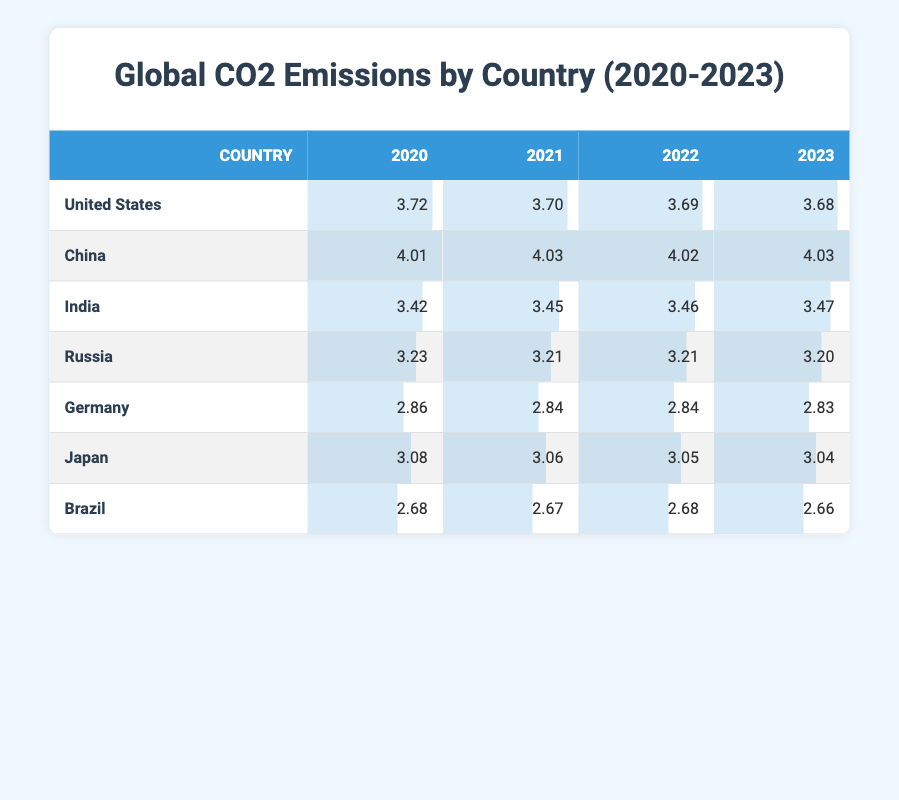What was the emission value for China in 2023? In the table, we can find the row for China, and under the column for 2023, the emission value is 4.03.
Answer: 4.03 Which country had the lowest CO2 emissions in 2022? By comparing all the countries' emissions in 2022, Brazil has the lowest value listed, which is 2.68.
Answer: Brazil What is the average CO2 emission for Russia from 2020 to 2023? To calculate the average, we sum the emissions from 2020 to 2023: (3.23 + 3.21 + 3.21 + 3.20) = 12.85. Then we divide by 4 (the number of years), resulting in an average of 12.85 / 4 = 3.2125.
Answer: 3.21 Did the emissions in Germany decrease from 2020 to 2023? By examining the emissions in Germany for each year, we find: 2020 was 2.86, decreasing to 2.83 in 2023. This confirms that emissions did decrease over this period.
Answer: Yes Which country shows the least variation in emissions over the four years? Analyzing the emissions for each country from 2020 to 2023, Brazil shows minimal fluctuation: 2.68, 2.67, 2.68, and 2.66, indicating a very consistent emissions level.
Answer: Brazil 